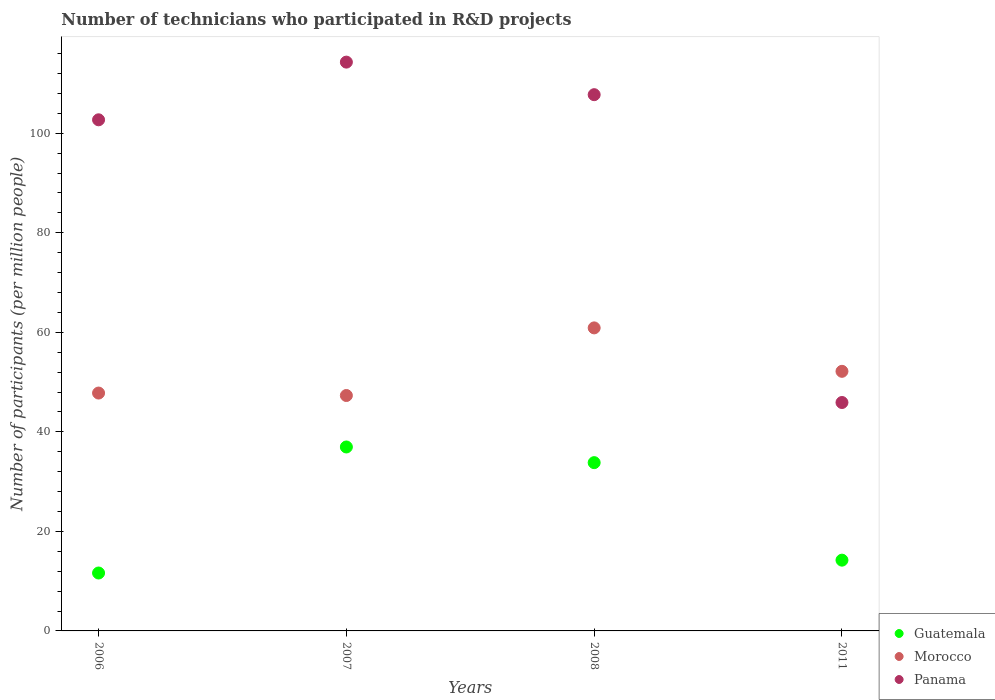Is the number of dotlines equal to the number of legend labels?
Give a very brief answer. Yes. What is the number of technicians who participated in R&D projects in Morocco in 2011?
Ensure brevity in your answer.  52.16. Across all years, what is the maximum number of technicians who participated in R&D projects in Panama?
Your response must be concise. 114.3. Across all years, what is the minimum number of technicians who participated in R&D projects in Guatemala?
Provide a short and direct response. 11.64. In which year was the number of technicians who participated in R&D projects in Guatemala minimum?
Keep it short and to the point. 2006. What is the total number of technicians who participated in R&D projects in Panama in the graph?
Provide a succinct answer. 370.66. What is the difference between the number of technicians who participated in R&D projects in Guatemala in 2007 and that in 2008?
Your response must be concise. 3.15. What is the difference between the number of technicians who participated in R&D projects in Panama in 2006 and the number of technicians who participated in R&D projects in Guatemala in 2007?
Offer a very short reply. 65.74. What is the average number of technicians who participated in R&D projects in Guatemala per year?
Keep it short and to the point. 24.16. In the year 2011, what is the difference between the number of technicians who participated in R&D projects in Panama and number of technicians who participated in R&D projects in Guatemala?
Provide a short and direct response. 31.68. In how many years, is the number of technicians who participated in R&D projects in Panama greater than 56?
Your answer should be very brief. 3. What is the ratio of the number of technicians who participated in R&D projects in Morocco in 2007 to that in 2008?
Give a very brief answer. 0.78. Is the difference between the number of technicians who participated in R&D projects in Panama in 2007 and 2008 greater than the difference between the number of technicians who participated in R&D projects in Guatemala in 2007 and 2008?
Keep it short and to the point. Yes. What is the difference between the highest and the second highest number of technicians who participated in R&D projects in Panama?
Offer a terse response. 6.54. What is the difference between the highest and the lowest number of technicians who participated in R&D projects in Morocco?
Provide a short and direct response. 13.59. Is the sum of the number of technicians who participated in R&D projects in Morocco in 2006 and 2007 greater than the maximum number of technicians who participated in R&D projects in Panama across all years?
Give a very brief answer. No. Does the number of technicians who participated in R&D projects in Morocco monotonically increase over the years?
Offer a terse response. No. How many years are there in the graph?
Provide a succinct answer. 4. Are the values on the major ticks of Y-axis written in scientific E-notation?
Ensure brevity in your answer.  No. Does the graph contain any zero values?
Provide a short and direct response. No. How many legend labels are there?
Your answer should be very brief. 3. How are the legend labels stacked?
Provide a short and direct response. Vertical. What is the title of the graph?
Provide a short and direct response. Number of technicians who participated in R&D projects. What is the label or title of the Y-axis?
Provide a succinct answer. Number of participants (per million people). What is the Number of participants (per million people) in Guatemala in 2006?
Provide a succinct answer. 11.64. What is the Number of participants (per million people) in Morocco in 2006?
Your response must be concise. 47.8. What is the Number of participants (per million people) in Panama in 2006?
Give a very brief answer. 102.71. What is the Number of participants (per million people) in Guatemala in 2007?
Offer a very short reply. 36.96. What is the Number of participants (per million people) of Morocco in 2007?
Your answer should be very brief. 47.31. What is the Number of participants (per million people) of Panama in 2007?
Provide a short and direct response. 114.3. What is the Number of participants (per million people) of Guatemala in 2008?
Offer a terse response. 33.81. What is the Number of participants (per million people) in Morocco in 2008?
Your response must be concise. 60.89. What is the Number of participants (per million people) in Panama in 2008?
Make the answer very short. 107.75. What is the Number of participants (per million people) of Guatemala in 2011?
Your response must be concise. 14.22. What is the Number of participants (per million people) of Morocco in 2011?
Make the answer very short. 52.16. What is the Number of participants (per million people) in Panama in 2011?
Your answer should be very brief. 45.9. Across all years, what is the maximum Number of participants (per million people) in Guatemala?
Your response must be concise. 36.96. Across all years, what is the maximum Number of participants (per million people) of Morocco?
Ensure brevity in your answer.  60.89. Across all years, what is the maximum Number of participants (per million people) of Panama?
Your answer should be very brief. 114.3. Across all years, what is the minimum Number of participants (per million people) of Guatemala?
Your answer should be compact. 11.64. Across all years, what is the minimum Number of participants (per million people) of Morocco?
Ensure brevity in your answer.  47.31. Across all years, what is the minimum Number of participants (per million people) of Panama?
Your response must be concise. 45.9. What is the total Number of participants (per million people) of Guatemala in the graph?
Your answer should be very brief. 96.63. What is the total Number of participants (per million people) in Morocco in the graph?
Provide a succinct answer. 208.16. What is the total Number of participants (per million people) in Panama in the graph?
Keep it short and to the point. 370.66. What is the difference between the Number of participants (per million people) in Guatemala in 2006 and that in 2007?
Make the answer very short. -25.32. What is the difference between the Number of participants (per million people) of Morocco in 2006 and that in 2007?
Give a very brief answer. 0.49. What is the difference between the Number of participants (per million people) of Panama in 2006 and that in 2007?
Make the answer very short. -11.59. What is the difference between the Number of participants (per million people) of Guatemala in 2006 and that in 2008?
Provide a short and direct response. -22.18. What is the difference between the Number of participants (per million people) of Morocco in 2006 and that in 2008?
Your response must be concise. -13.09. What is the difference between the Number of participants (per million people) of Panama in 2006 and that in 2008?
Your answer should be very brief. -5.05. What is the difference between the Number of participants (per million people) of Guatemala in 2006 and that in 2011?
Your answer should be very brief. -2.58. What is the difference between the Number of participants (per million people) of Morocco in 2006 and that in 2011?
Give a very brief answer. -4.37. What is the difference between the Number of participants (per million people) of Panama in 2006 and that in 2011?
Your answer should be compact. 56.81. What is the difference between the Number of participants (per million people) of Guatemala in 2007 and that in 2008?
Offer a terse response. 3.15. What is the difference between the Number of participants (per million people) of Morocco in 2007 and that in 2008?
Keep it short and to the point. -13.59. What is the difference between the Number of participants (per million people) of Panama in 2007 and that in 2008?
Your answer should be compact. 6.54. What is the difference between the Number of participants (per million people) of Guatemala in 2007 and that in 2011?
Ensure brevity in your answer.  22.74. What is the difference between the Number of participants (per million people) in Morocco in 2007 and that in 2011?
Provide a short and direct response. -4.86. What is the difference between the Number of participants (per million people) of Panama in 2007 and that in 2011?
Offer a very short reply. 68.4. What is the difference between the Number of participants (per million people) in Guatemala in 2008 and that in 2011?
Ensure brevity in your answer.  19.59. What is the difference between the Number of participants (per million people) of Morocco in 2008 and that in 2011?
Offer a very short reply. 8.73. What is the difference between the Number of participants (per million people) in Panama in 2008 and that in 2011?
Offer a terse response. 61.86. What is the difference between the Number of participants (per million people) in Guatemala in 2006 and the Number of participants (per million people) in Morocco in 2007?
Ensure brevity in your answer.  -35.67. What is the difference between the Number of participants (per million people) in Guatemala in 2006 and the Number of participants (per million people) in Panama in 2007?
Provide a succinct answer. -102.66. What is the difference between the Number of participants (per million people) in Morocco in 2006 and the Number of participants (per million people) in Panama in 2007?
Your answer should be very brief. -66.5. What is the difference between the Number of participants (per million people) in Guatemala in 2006 and the Number of participants (per million people) in Morocco in 2008?
Make the answer very short. -49.25. What is the difference between the Number of participants (per million people) in Guatemala in 2006 and the Number of participants (per million people) in Panama in 2008?
Your answer should be very brief. -96.12. What is the difference between the Number of participants (per million people) of Morocco in 2006 and the Number of participants (per million people) of Panama in 2008?
Provide a succinct answer. -59.96. What is the difference between the Number of participants (per million people) of Guatemala in 2006 and the Number of participants (per million people) of Morocco in 2011?
Give a very brief answer. -40.53. What is the difference between the Number of participants (per million people) of Guatemala in 2006 and the Number of participants (per million people) of Panama in 2011?
Offer a very short reply. -34.26. What is the difference between the Number of participants (per million people) in Morocco in 2006 and the Number of participants (per million people) in Panama in 2011?
Your answer should be very brief. 1.9. What is the difference between the Number of participants (per million people) in Guatemala in 2007 and the Number of participants (per million people) in Morocco in 2008?
Offer a terse response. -23.93. What is the difference between the Number of participants (per million people) of Guatemala in 2007 and the Number of participants (per million people) of Panama in 2008?
Provide a short and direct response. -70.79. What is the difference between the Number of participants (per million people) of Morocco in 2007 and the Number of participants (per million people) of Panama in 2008?
Ensure brevity in your answer.  -60.45. What is the difference between the Number of participants (per million people) of Guatemala in 2007 and the Number of participants (per million people) of Morocco in 2011?
Your answer should be compact. -15.2. What is the difference between the Number of participants (per million people) in Guatemala in 2007 and the Number of participants (per million people) in Panama in 2011?
Your answer should be very brief. -8.94. What is the difference between the Number of participants (per million people) of Morocco in 2007 and the Number of participants (per million people) of Panama in 2011?
Offer a very short reply. 1.41. What is the difference between the Number of participants (per million people) of Guatemala in 2008 and the Number of participants (per million people) of Morocco in 2011?
Your response must be concise. -18.35. What is the difference between the Number of participants (per million people) in Guatemala in 2008 and the Number of participants (per million people) in Panama in 2011?
Provide a short and direct response. -12.09. What is the difference between the Number of participants (per million people) of Morocco in 2008 and the Number of participants (per million people) of Panama in 2011?
Ensure brevity in your answer.  14.99. What is the average Number of participants (per million people) in Guatemala per year?
Make the answer very short. 24.16. What is the average Number of participants (per million people) in Morocco per year?
Your answer should be very brief. 52.04. What is the average Number of participants (per million people) in Panama per year?
Offer a very short reply. 92.66. In the year 2006, what is the difference between the Number of participants (per million people) in Guatemala and Number of participants (per million people) in Morocco?
Your answer should be compact. -36.16. In the year 2006, what is the difference between the Number of participants (per million people) in Guatemala and Number of participants (per million people) in Panama?
Offer a very short reply. -91.07. In the year 2006, what is the difference between the Number of participants (per million people) of Morocco and Number of participants (per million people) of Panama?
Provide a short and direct response. -54.91. In the year 2007, what is the difference between the Number of participants (per million people) of Guatemala and Number of participants (per million people) of Morocco?
Your response must be concise. -10.34. In the year 2007, what is the difference between the Number of participants (per million people) of Guatemala and Number of participants (per million people) of Panama?
Offer a terse response. -77.33. In the year 2007, what is the difference between the Number of participants (per million people) in Morocco and Number of participants (per million people) in Panama?
Your answer should be compact. -66.99. In the year 2008, what is the difference between the Number of participants (per million people) in Guatemala and Number of participants (per million people) in Morocco?
Provide a succinct answer. -27.08. In the year 2008, what is the difference between the Number of participants (per million people) in Guatemala and Number of participants (per million people) in Panama?
Your answer should be very brief. -73.94. In the year 2008, what is the difference between the Number of participants (per million people) in Morocco and Number of participants (per million people) in Panama?
Your answer should be compact. -46.86. In the year 2011, what is the difference between the Number of participants (per million people) in Guatemala and Number of participants (per million people) in Morocco?
Keep it short and to the point. -37.94. In the year 2011, what is the difference between the Number of participants (per million people) of Guatemala and Number of participants (per million people) of Panama?
Offer a terse response. -31.68. In the year 2011, what is the difference between the Number of participants (per million people) in Morocco and Number of participants (per million people) in Panama?
Your answer should be very brief. 6.26. What is the ratio of the Number of participants (per million people) in Guatemala in 2006 to that in 2007?
Your answer should be very brief. 0.31. What is the ratio of the Number of participants (per million people) in Morocco in 2006 to that in 2007?
Your answer should be compact. 1.01. What is the ratio of the Number of participants (per million people) of Panama in 2006 to that in 2007?
Offer a terse response. 0.9. What is the ratio of the Number of participants (per million people) in Guatemala in 2006 to that in 2008?
Your answer should be compact. 0.34. What is the ratio of the Number of participants (per million people) in Morocco in 2006 to that in 2008?
Make the answer very short. 0.79. What is the ratio of the Number of participants (per million people) of Panama in 2006 to that in 2008?
Keep it short and to the point. 0.95. What is the ratio of the Number of participants (per million people) in Guatemala in 2006 to that in 2011?
Your response must be concise. 0.82. What is the ratio of the Number of participants (per million people) of Morocco in 2006 to that in 2011?
Offer a terse response. 0.92. What is the ratio of the Number of participants (per million people) in Panama in 2006 to that in 2011?
Offer a terse response. 2.24. What is the ratio of the Number of participants (per million people) in Guatemala in 2007 to that in 2008?
Your answer should be very brief. 1.09. What is the ratio of the Number of participants (per million people) in Morocco in 2007 to that in 2008?
Offer a terse response. 0.78. What is the ratio of the Number of participants (per million people) in Panama in 2007 to that in 2008?
Provide a succinct answer. 1.06. What is the ratio of the Number of participants (per million people) in Guatemala in 2007 to that in 2011?
Your answer should be compact. 2.6. What is the ratio of the Number of participants (per million people) in Morocco in 2007 to that in 2011?
Offer a very short reply. 0.91. What is the ratio of the Number of participants (per million people) in Panama in 2007 to that in 2011?
Provide a short and direct response. 2.49. What is the ratio of the Number of participants (per million people) of Guatemala in 2008 to that in 2011?
Your response must be concise. 2.38. What is the ratio of the Number of participants (per million people) of Morocco in 2008 to that in 2011?
Your response must be concise. 1.17. What is the ratio of the Number of participants (per million people) in Panama in 2008 to that in 2011?
Provide a short and direct response. 2.35. What is the difference between the highest and the second highest Number of participants (per million people) of Guatemala?
Provide a succinct answer. 3.15. What is the difference between the highest and the second highest Number of participants (per million people) of Morocco?
Give a very brief answer. 8.73. What is the difference between the highest and the second highest Number of participants (per million people) of Panama?
Offer a very short reply. 6.54. What is the difference between the highest and the lowest Number of participants (per million people) of Guatemala?
Your response must be concise. 25.32. What is the difference between the highest and the lowest Number of participants (per million people) in Morocco?
Ensure brevity in your answer.  13.59. What is the difference between the highest and the lowest Number of participants (per million people) in Panama?
Make the answer very short. 68.4. 